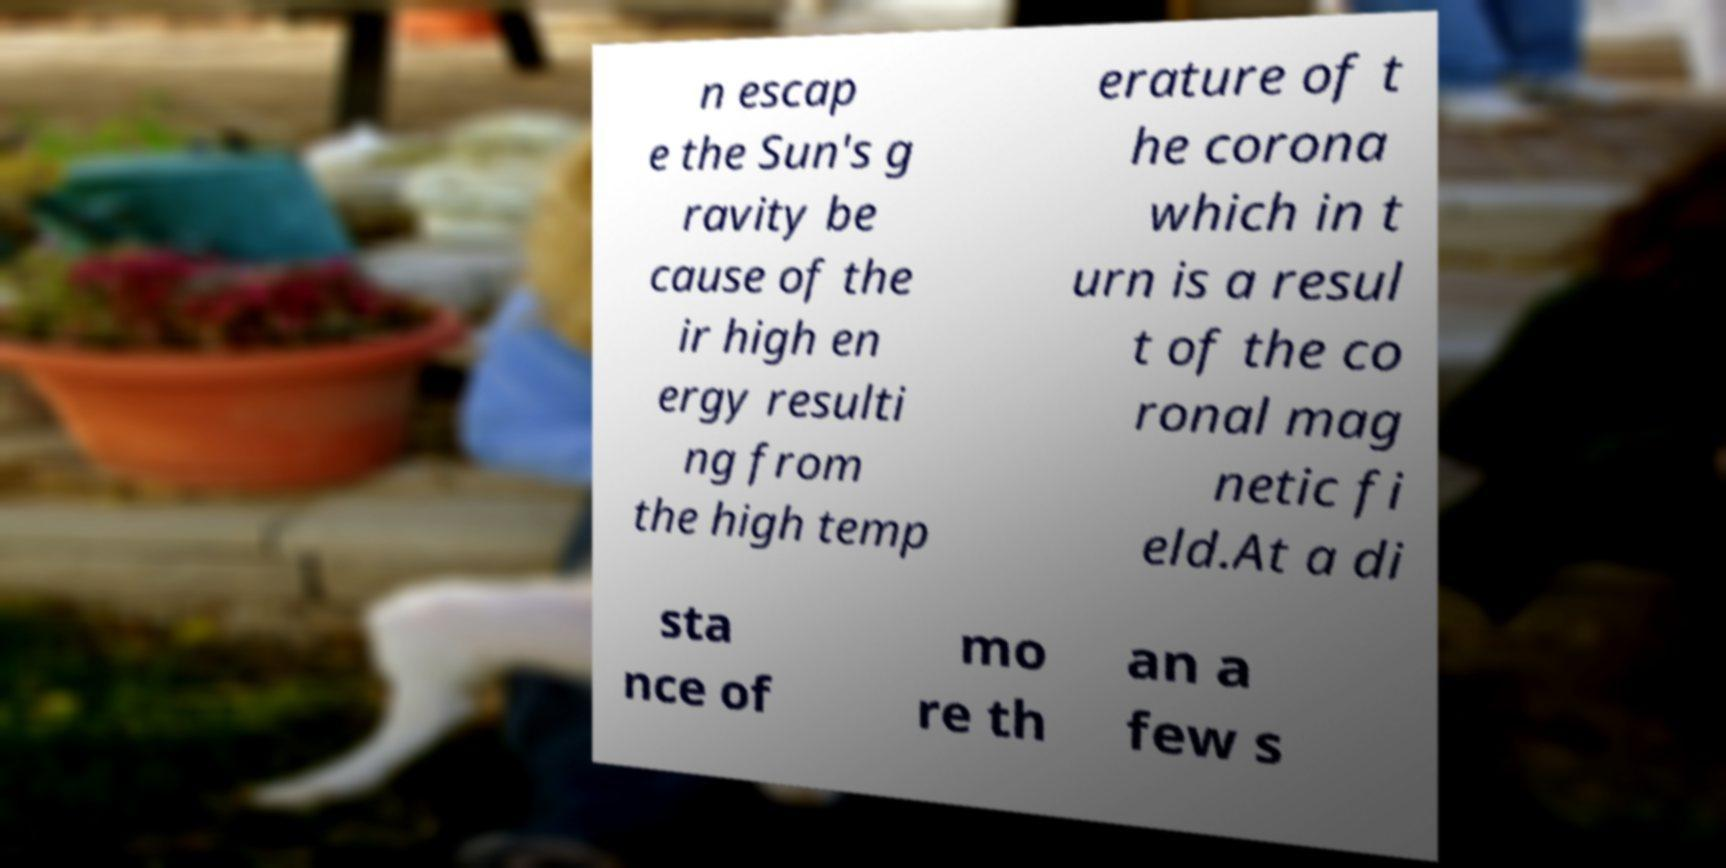There's text embedded in this image that I need extracted. Can you transcribe it verbatim? n escap e the Sun's g ravity be cause of the ir high en ergy resulti ng from the high temp erature of t he corona which in t urn is a resul t of the co ronal mag netic fi eld.At a di sta nce of mo re th an a few s 